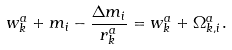<formula> <loc_0><loc_0><loc_500><loc_500>w _ { k } ^ { a } + m _ { i } - \frac { \Delta m _ { i } } { r _ { k } ^ { a } } = w _ { k } ^ { a } + \Omega _ { k , i } ^ { a } .</formula> 